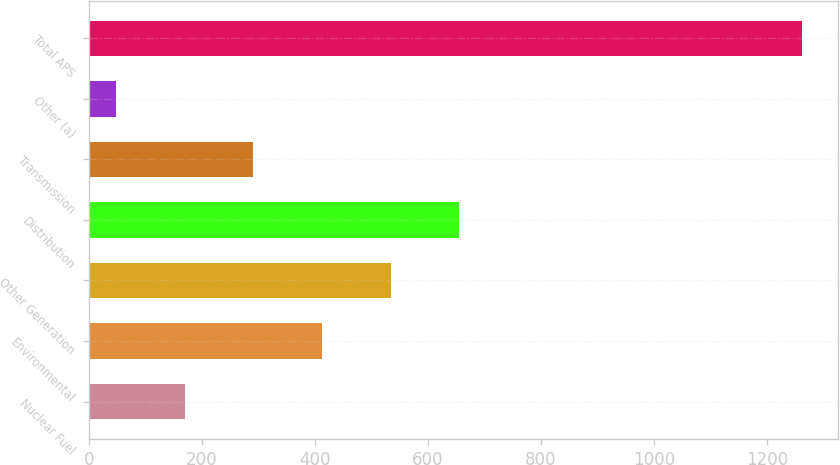<chart> <loc_0><loc_0><loc_500><loc_500><bar_chart><fcel>Nuclear Fuel<fcel>Environmental<fcel>Other Generation<fcel>Distribution<fcel>Transmission<fcel>Other (a)<fcel>Total APS<nl><fcel>169.5<fcel>412.5<fcel>534<fcel>655.5<fcel>291<fcel>48<fcel>1263<nl></chart> 